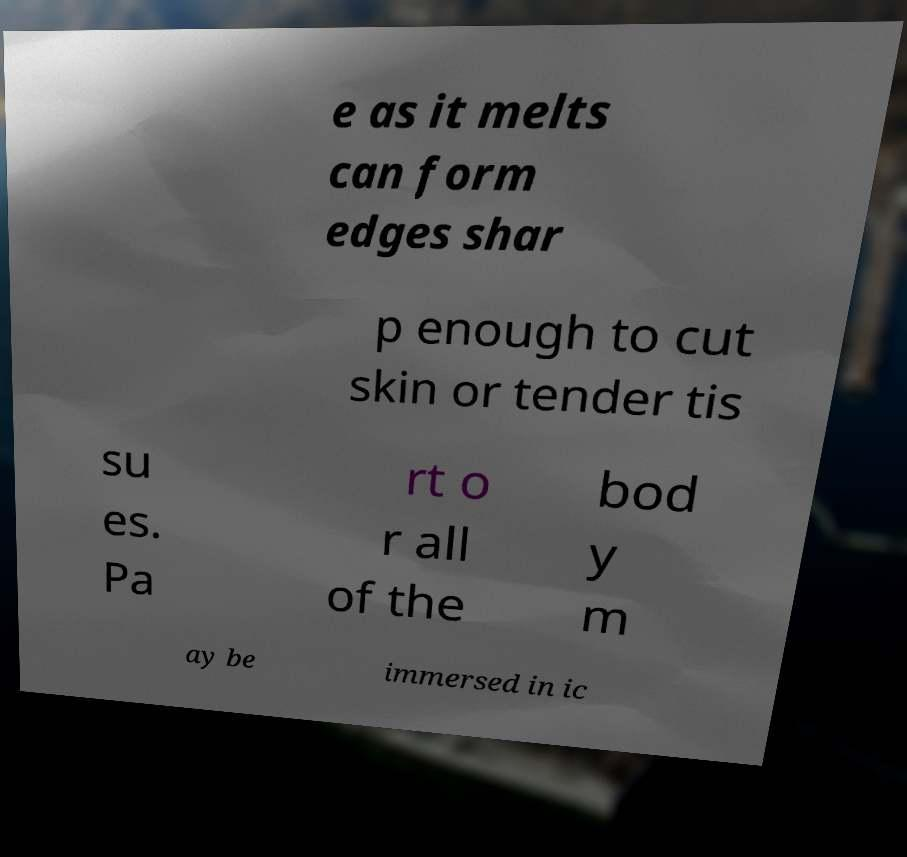Please identify and transcribe the text found in this image. e as it melts can form edges shar p enough to cut skin or tender tis su es. Pa rt o r all of the bod y m ay be immersed in ic 